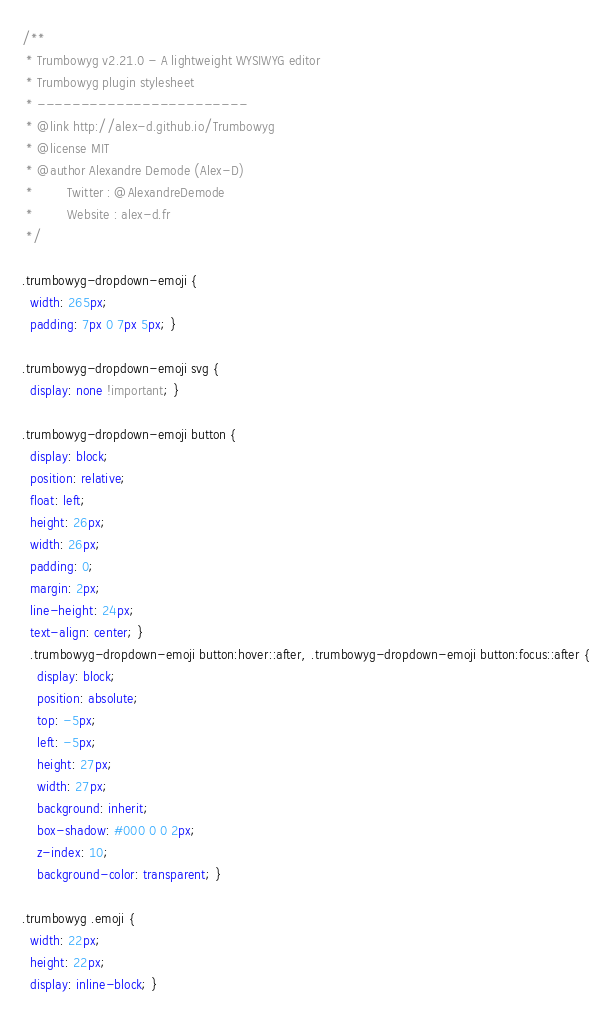<code> <loc_0><loc_0><loc_500><loc_500><_CSS_>/**
 * Trumbowyg v2.21.0 - A lightweight WYSIWYG editor
 * Trumbowyg plugin stylesheet
 * ------------------------
 * @link http://alex-d.github.io/Trumbowyg
 * @license MIT
 * @author Alexandre Demode (Alex-D)
 *         Twitter : @AlexandreDemode
 *         Website : alex-d.fr
 */

.trumbowyg-dropdown-emoji {
  width: 265px;
  padding: 7px 0 7px 5px; }

.trumbowyg-dropdown-emoji svg {
  display: none !important; }

.trumbowyg-dropdown-emoji button {
  display: block;
  position: relative;
  float: left;
  height: 26px;
  width: 26px;
  padding: 0;
  margin: 2px;
  line-height: 24px;
  text-align: center; }
  .trumbowyg-dropdown-emoji button:hover::after, .trumbowyg-dropdown-emoji button:focus::after {
    display: block;
    position: absolute;
    top: -5px;
    left: -5px;
    height: 27px;
    width: 27px;
    background: inherit;
    box-shadow: #000 0 0 2px;
    z-index: 10;
    background-color: transparent; }

.trumbowyg .emoji {
  width: 22px;
  height: 22px;
  display: inline-block; }
</code> 